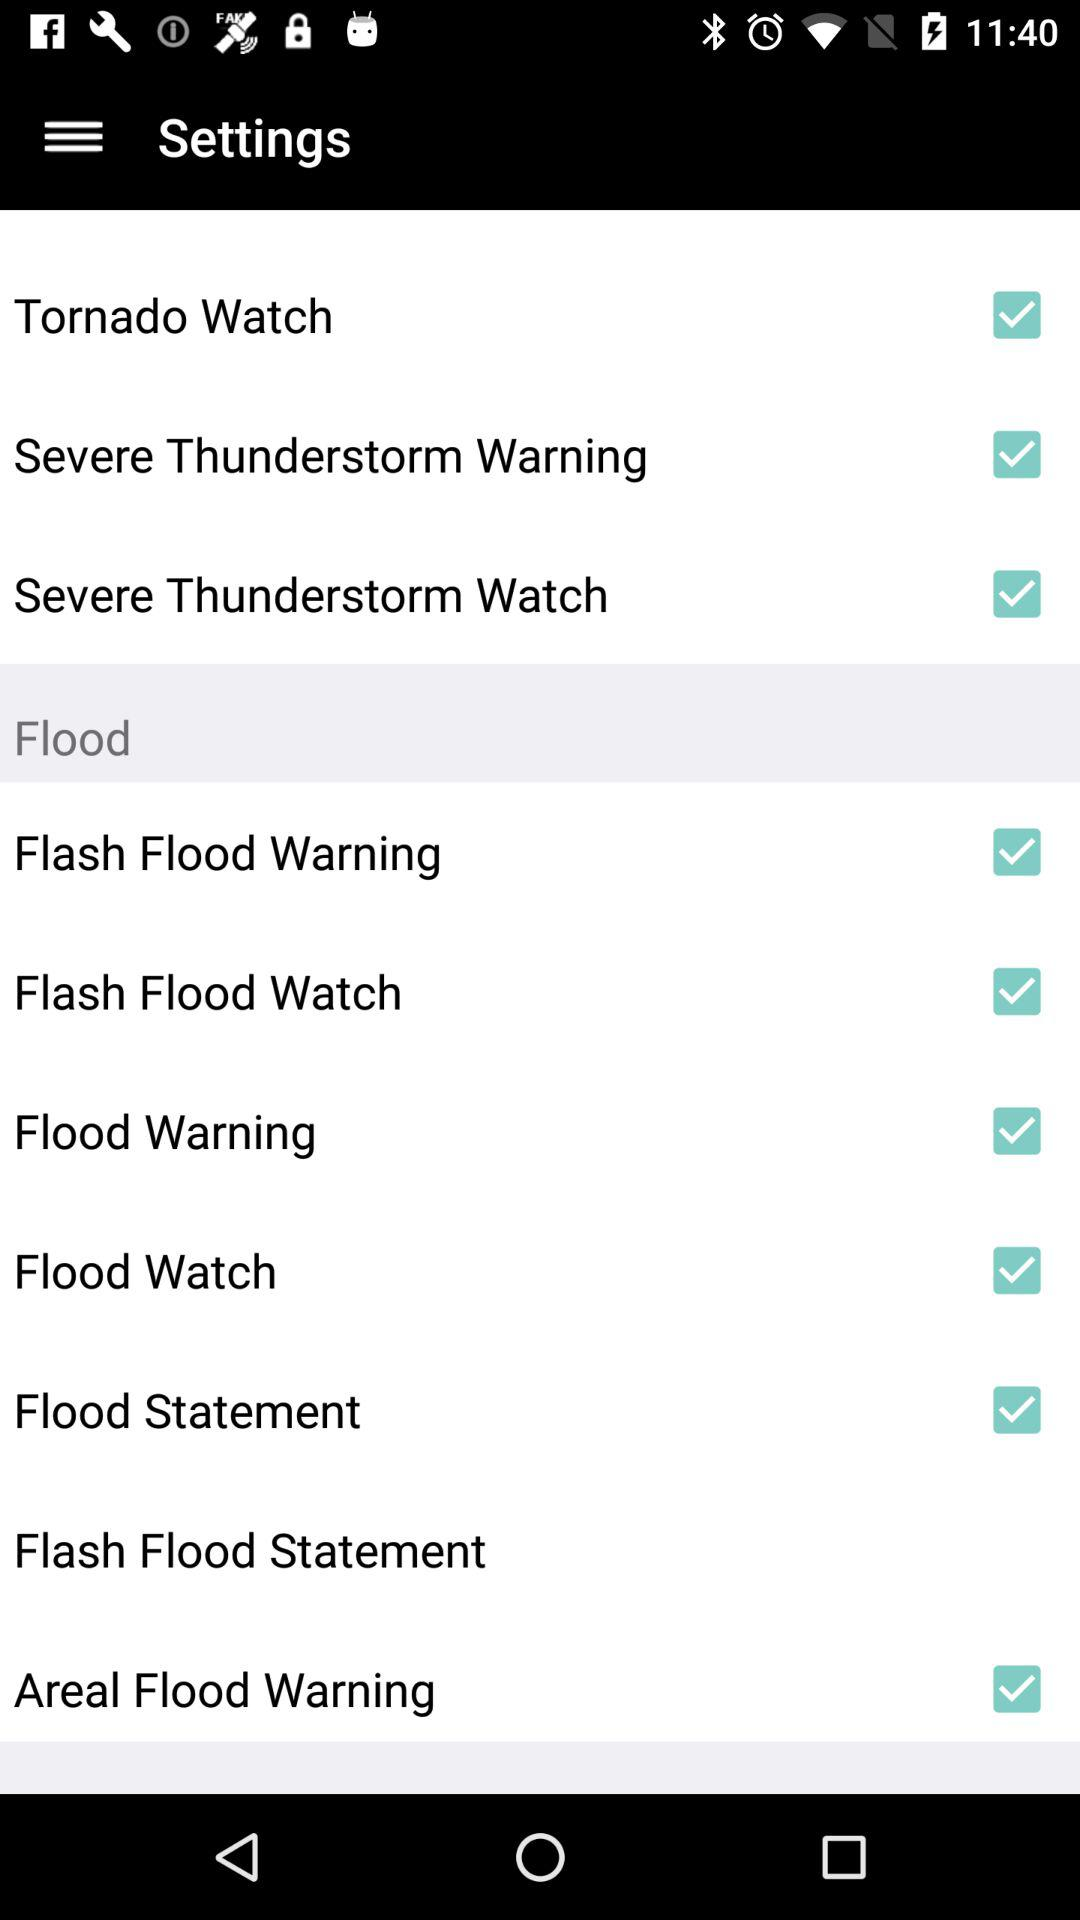What is the current status of the "Tornado Watch"? The status is on. 